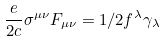<formula> <loc_0><loc_0><loc_500><loc_500>\frac { e } { 2 c } \sigma ^ { \mu \nu } F _ { \mu \nu } = 1 / 2 f ^ { \lambda } \gamma _ { \lambda }</formula> 